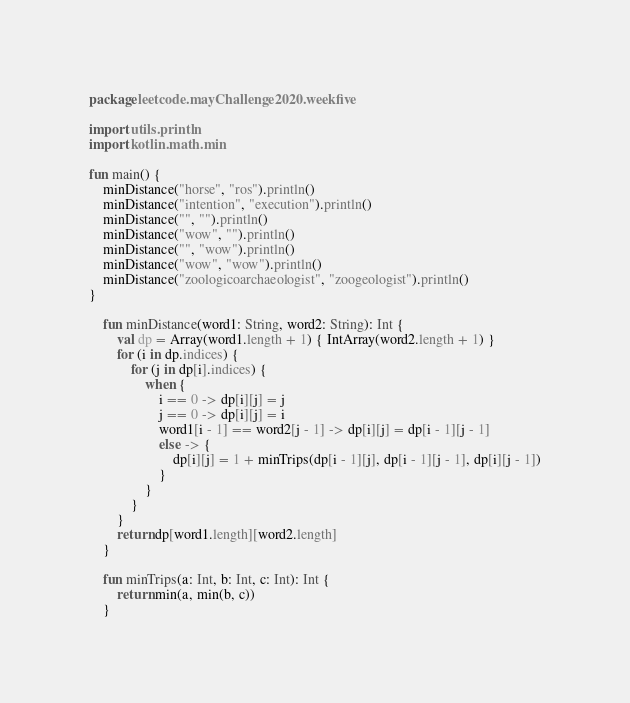<code> <loc_0><loc_0><loc_500><loc_500><_Kotlin_>package leetcode.mayChallenge2020.weekfive

import utils.println
import kotlin.math.min

fun main() {
    minDistance("horse", "ros").println()
    minDistance("intention", "execution").println()
    minDistance("", "").println()
    minDistance("wow", "").println()
    minDistance("", "wow").println()
    minDistance("wow", "wow").println()
    minDistance("zoologicoarchaeologist", "zoogeologist").println()
}
    
    fun minDistance(word1: String, word2: String): Int {
        val dp = Array(word1.length + 1) { IntArray(word2.length + 1) }
        for (i in dp.indices) {
            for (j in dp[i].indices) {
                when {
                    i == 0 -> dp[i][j] = j
                    j == 0 -> dp[i][j] = i
                    word1[i - 1] == word2[j - 1] -> dp[i][j] = dp[i - 1][j - 1]
                    else -> {
                        dp[i][j] = 1 + minTrips(dp[i - 1][j], dp[i - 1][j - 1], dp[i][j - 1])
                    }
                }
            }
        }
        return dp[word1.length][word2.length]
    }

    fun minTrips(a: Int, b: Int, c: Int): Int {
        return min(a, min(b, c))
    }</code> 